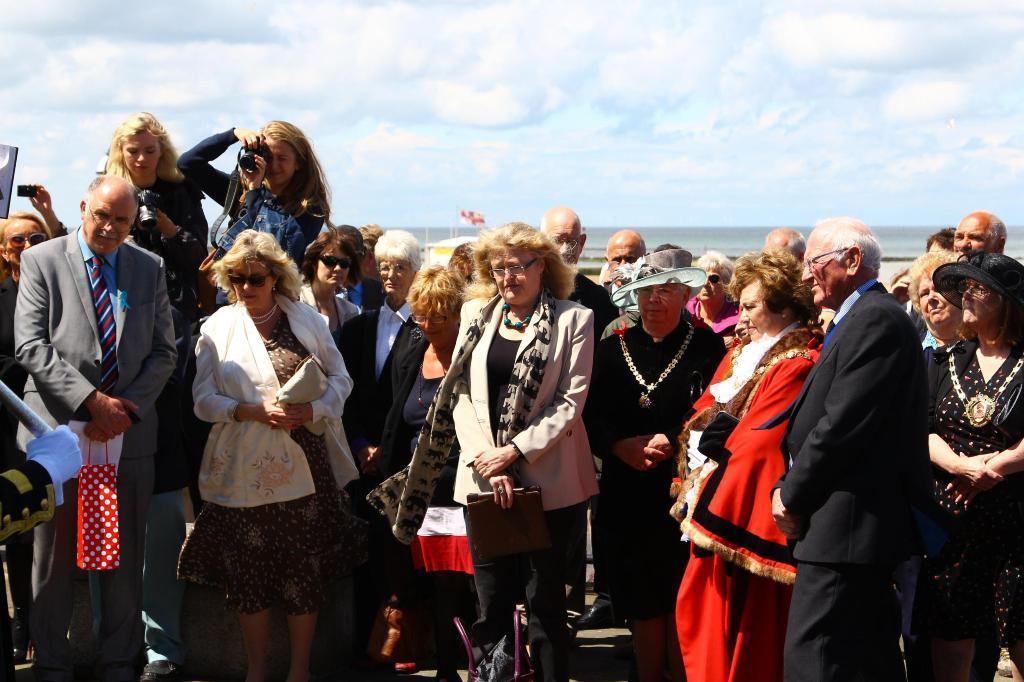Could you give a brief overview of what you see in this image? In the picture I can see group of people are standing among them some are wearing hats, ornaments, hats and other objects. Here I can see this woman is holding a camera. In the background I can see the sky. 